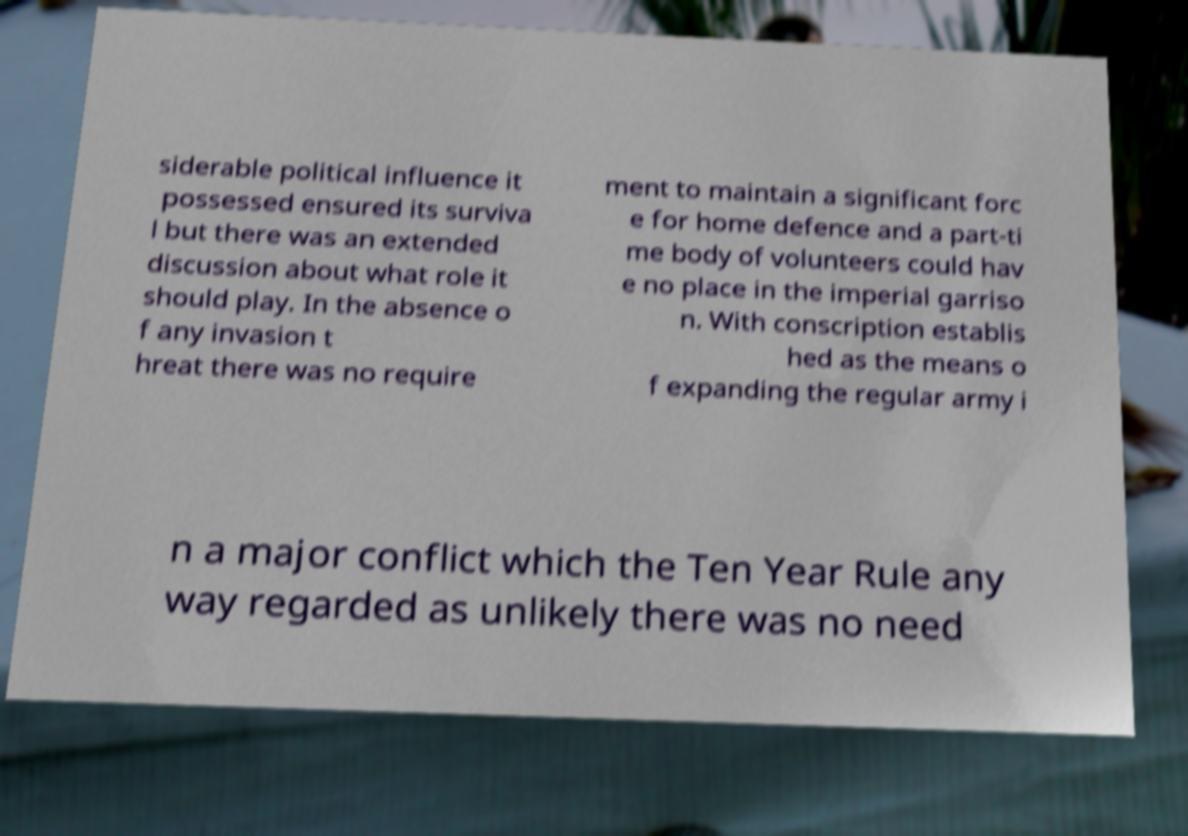What messages or text are displayed in this image? I need them in a readable, typed format. siderable political influence it possessed ensured its surviva l but there was an extended discussion about what role it should play. In the absence o f any invasion t hreat there was no require ment to maintain a significant forc e for home defence and a part-ti me body of volunteers could hav e no place in the imperial garriso n. With conscription establis hed as the means o f expanding the regular army i n a major conflict which the Ten Year Rule any way regarded as unlikely there was no need 